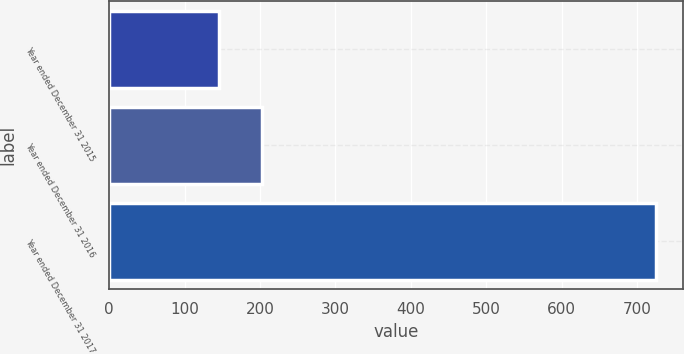<chart> <loc_0><loc_0><loc_500><loc_500><bar_chart><fcel>Year ended December 31 2015<fcel>Year ended December 31 2016<fcel>Year ended December 31 2017<nl><fcel>145<fcel>203<fcel>725<nl></chart> 